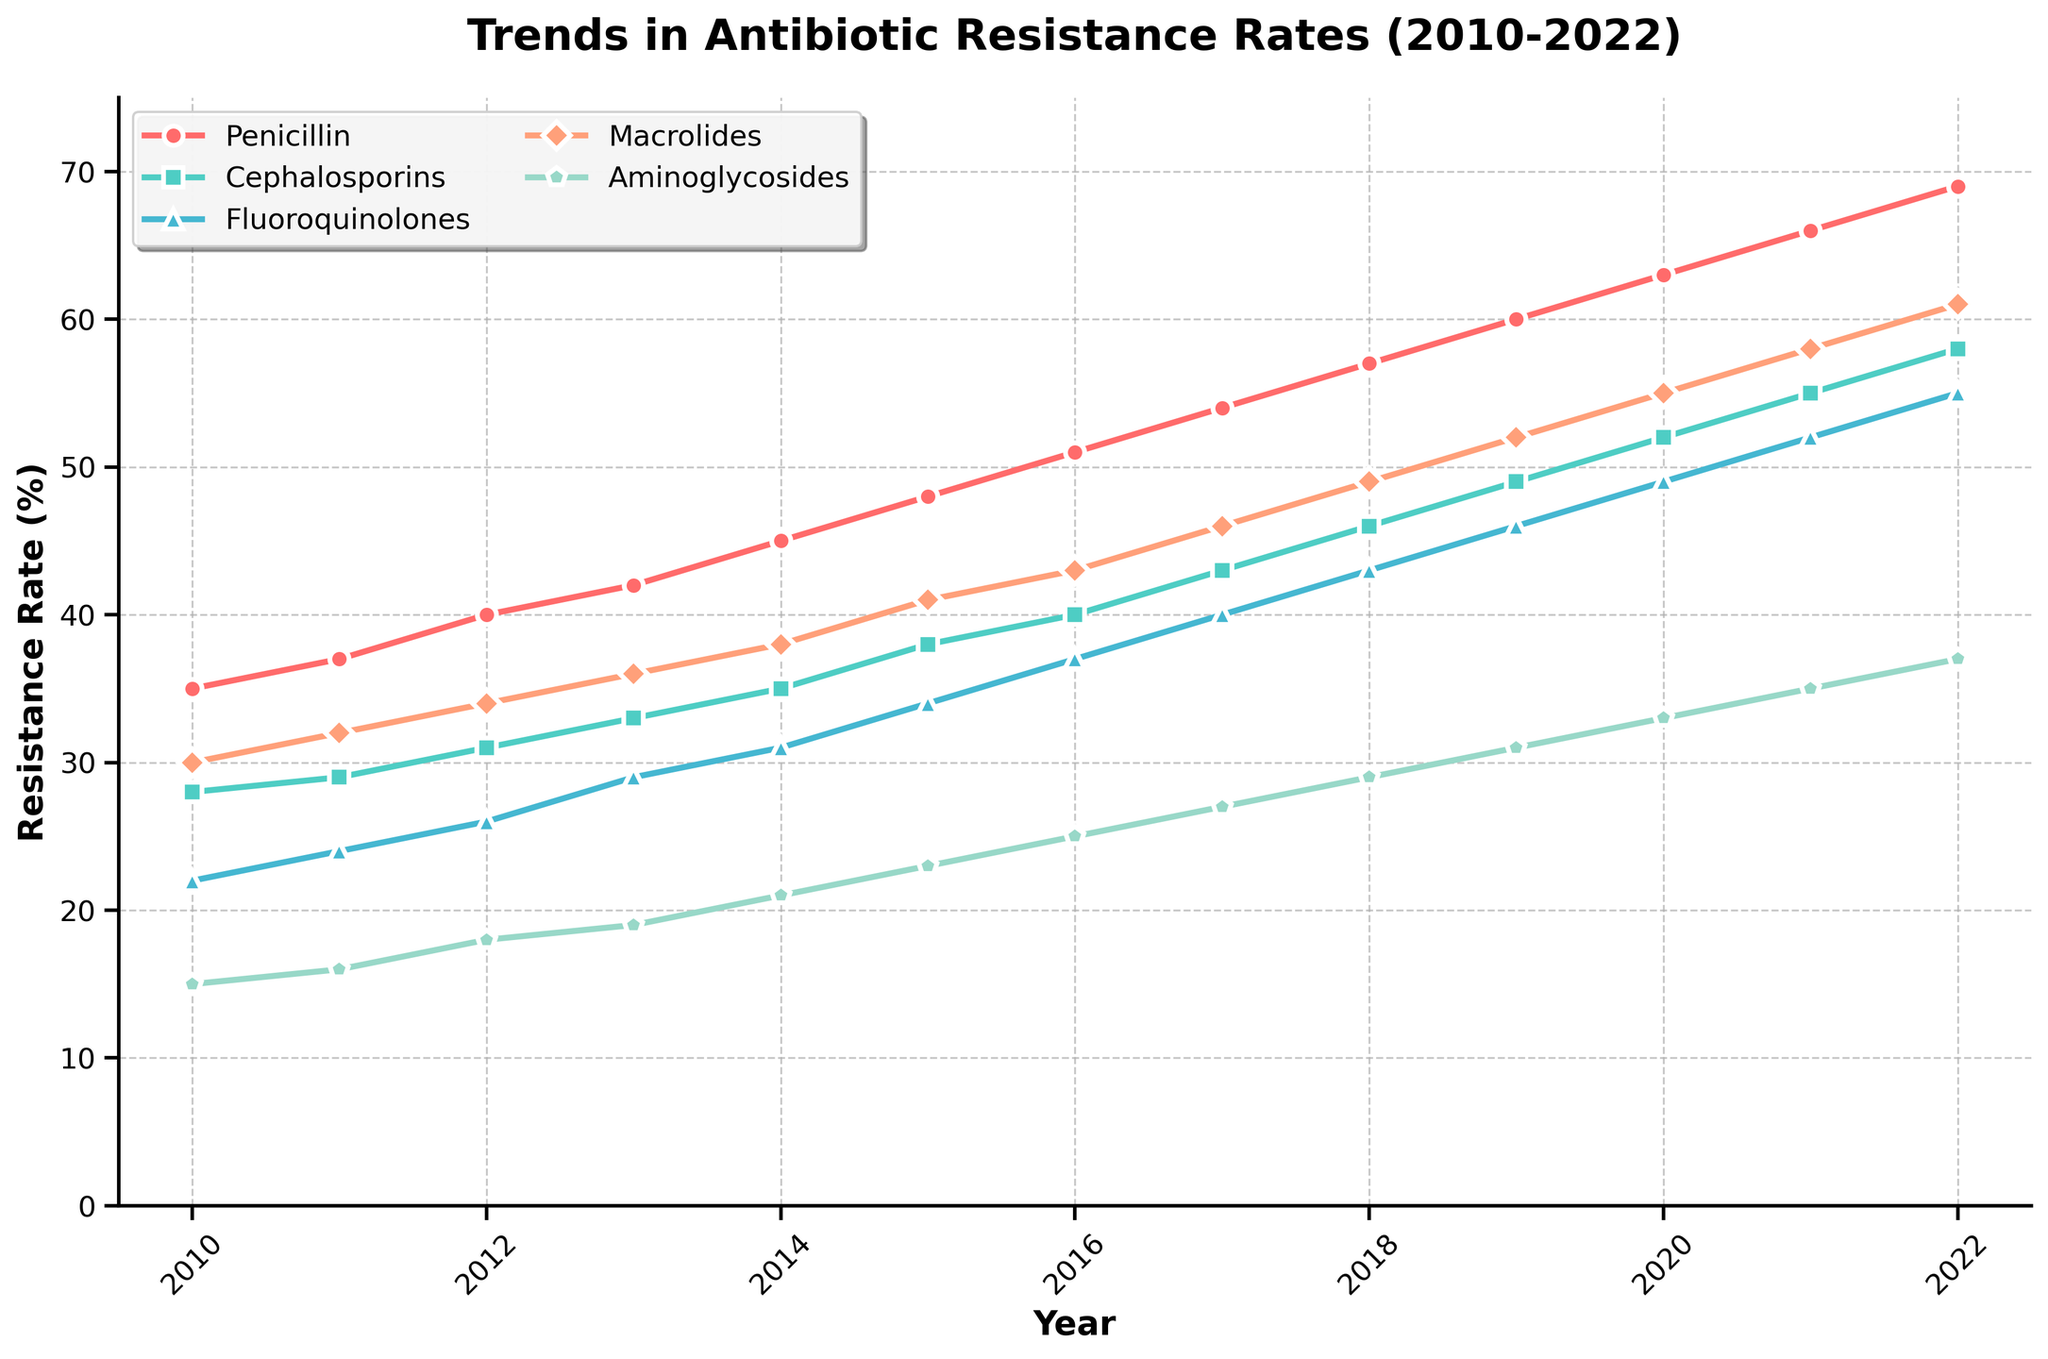Which antibiotic showed the highest increase in resistance rate from 2010 to 2022? To find the highest increase, we need to calculate the difference between the resistance rates in 2022 and 2010 for each antibiotic. Penicillin: 69-35=34; Cephalosporins: 58-28=30; Fluoroquinolones: 55-22=33; Macrolides: 61-30=31; Aminoglycosides: 37-15=22. Penicillin shows the highest increase.
Answer: Penicillin Which antibiotic had the lowest resistance rate in 2022? Examine the resistance rate values for each antibiotic in 2022: Penicillin=69, Cephalosporins=58, Fluoroquinolones=55, Macrolides=61, Aminoglycosides=37. The lowest rate is 37 for Aminoglycosides.
Answer: Aminoglycosides In which year did Macrolides surpass a 50% resistance rate? Look at the resistance rates for Macrolides each year. Macrolides surpasses 50% in 2020 with a rate of 55.
Answer: 2020 Between which two consecutive years did Fluoroquinolones show the greatest increase in resistance rate? Calculate the yearly difference for Fluoroquinolones: 2011-2010=2; 2012-2011=2; 2013-2012=3; 2014-2013=2; 2015-2014=3; 2016-2015=3; 2017-2016=3; 2018-2017=3; 2019-2018=3; 2020-2019=3; 2021-2020=3; 2022-2021=3. The greatest single-year increase is 3 and it occurred in multiple instances (mostly between 2013-2014 and onwards).
Answer: 2013-2014 (and others) By what percentage did the resistance rate for Cephalosporins increase from 2015 to 2022? Subtract the 2015 rate from the 2022 rate and then divide by the 2015 rate and multiply by 100. (58-38)/38*100 = 52.63%
Answer: 52.63% What is the average resistance rate of Penicillin over the years 2010 to 2022? Sum the values from 2010 to 2022 and then divide by the number of years: (35+37+40+42+45+48+51+54+57+60+63+66+69)/13 ≈ 50.
Answer: 50 Which antibiotic had the sharpest visual trend with the steepest line at any point on the graph? Visually identify the steepest line between any two points. Penicillin generally has the steepest upward slope overall.
Answer: Penicillin Did any antibiotic maintain a constant rate without any increase between any two consecutive years? Visually inspect to see if there are any flat lines between consecutive years. All antibiotics show increasing trends with no flat line segments.
Answer: No 